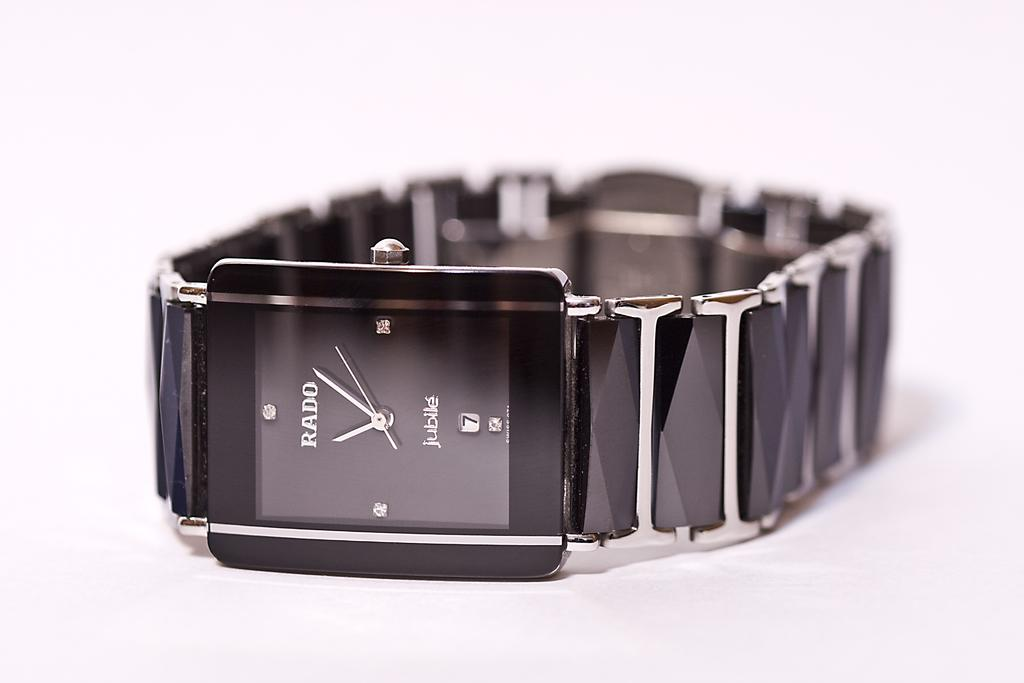<image>
Relay a brief, clear account of the picture shown. A Rado watch has a few crystals where the numbers should be. 